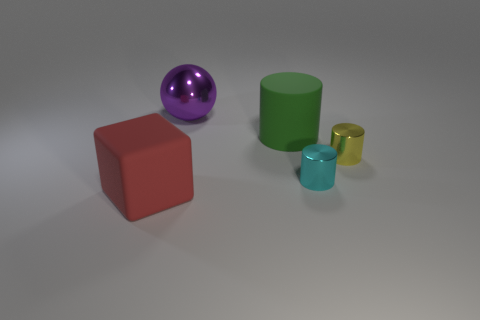How big is the object on the left side of the metallic object that is behind the big green object?
Provide a succinct answer. Large. How many other things are there of the same size as the cyan thing?
Your response must be concise. 1. There is a thing that is in front of the yellow thing and to the right of the red object; what is its size?
Offer a terse response. Small. How many tiny shiny objects have the same shape as the large green thing?
Your answer should be compact. 2. What is the material of the red cube?
Keep it short and to the point. Rubber. Is the shape of the yellow thing the same as the large red matte object?
Offer a very short reply. No. Are there any other tiny cylinders that have the same material as the tiny cyan cylinder?
Give a very brief answer. Yes. There is a metal thing that is both to the right of the big purple thing and left of the yellow metallic thing; what is its color?
Offer a terse response. Cyan. There is a large object on the left side of the large metal object; what material is it?
Your answer should be compact. Rubber. Are there any green rubber things of the same shape as the big red matte object?
Your answer should be compact. No. 